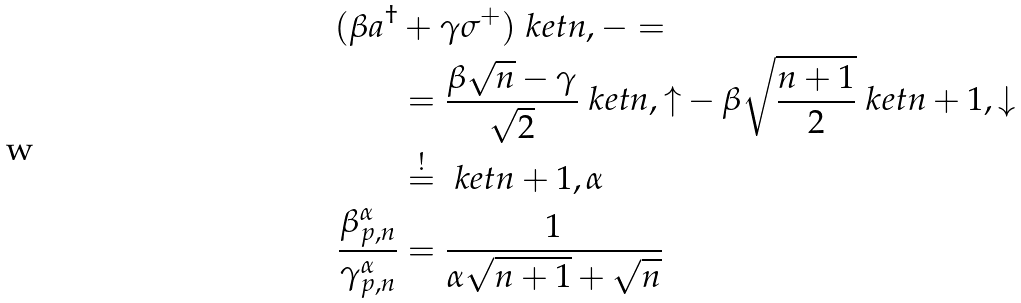Convert formula to latex. <formula><loc_0><loc_0><loc_500><loc_500>( \beta a ^ { \dagger } & + \gamma \sigma ^ { + } ) \ k e t { n , - } = \\ & = \frac { \beta \sqrt { n } - \gamma } { \sqrt { 2 } } \ k e t { n , \uparrow } - \beta \sqrt { \frac { n + 1 } { 2 } } \ k e t { n + 1 , \downarrow } \\ & \overset { ! } { = } \ k e t { n + 1 , \alpha } \\ \frac { \beta ^ { \alpha } _ { p , n } } { \gamma ^ { \alpha } _ { p , n } } & = \frac { 1 } { \alpha \sqrt { n + 1 } + \sqrt { n } }</formula> 